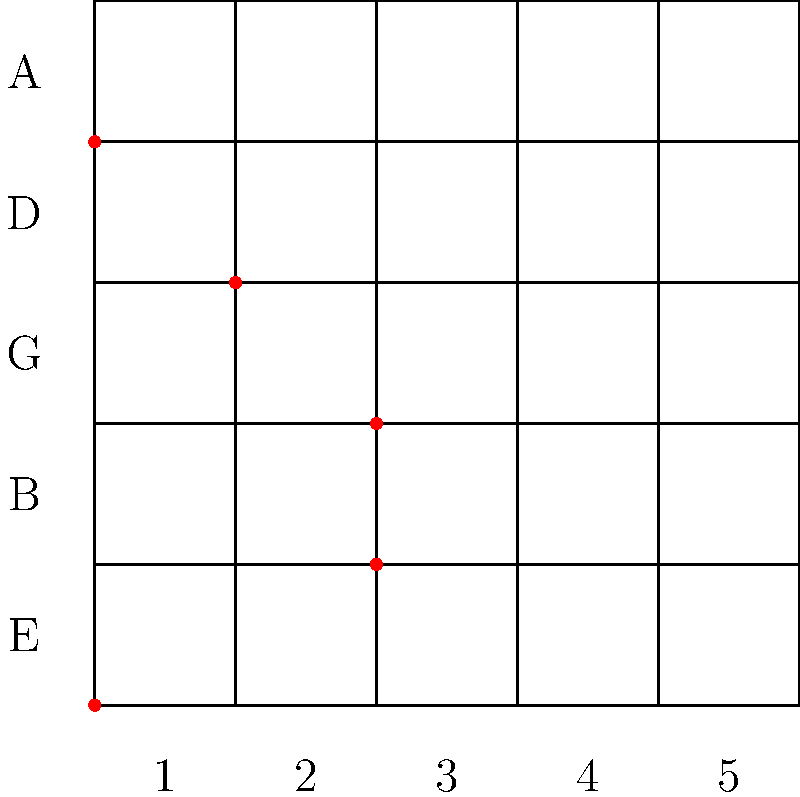In Shawn McDonald's hit song "Gravity," what chord is represented by the red dots on this guitar fretboard diagram, which forms a crucial part of the song's chord progression? To identify the chord represented in the fretboard diagram, let's follow these steps:

1. Analyze the finger positions (red dots) on each string:
   - E string (bottom): Open (0th fret)
   - B string: 2nd fret
   - G string: 2nd fret
   - D string: 1st fret
   - A string: Open (0th fret)
   - E string (top): Not played (no dot)

2. Determine the notes being played:
   - E (open E string)
   - F# (2nd fret on B string)
   - B (2nd fret on G string)
   - E (1st fret on D string)
   - A (open A string)

3. Analyze the chord structure:
   - Root note: E
   - Major third: G# (not present)
   - Perfect fifth: B
   - Major seventh: D# (not present)
   - Added fourth: A

4. Identify the chord:
   Given the structure and the absence of a major third (G#), this chord is an Esus4 (E suspended 4th) chord.

The Esus4 chord is a significant part of the chord progression in "Gravity," contributing to the song's emotive and introspective feel that Shawn McDonald is known for in his honest and authentic songwriting.
Answer: Esus4 